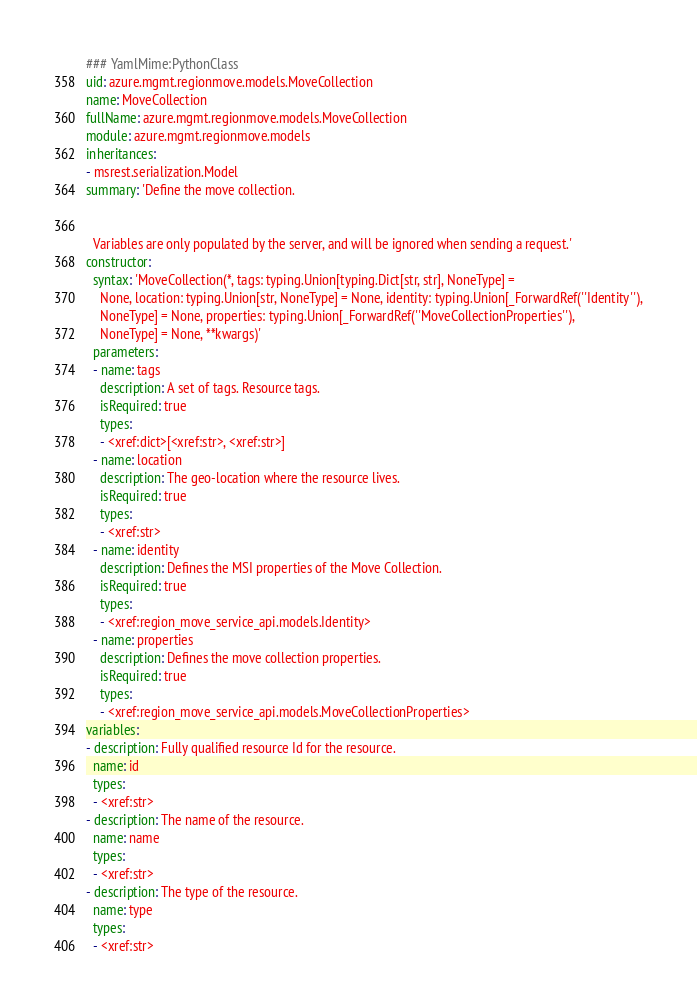Convert code to text. <code><loc_0><loc_0><loc_500><loc_500><_YAML_>### YamlMime:PythonClass
uid: azure.mgmt.regionmove.models.MoveCollection
name: MoveCollection
fullName: azure.mgmt.regionmove.models.MoveCollection
module: azure.mgmt.regionmove.models
inheritances:
- msrest.serialization.Model
summary: 'Define the move collection.


  Variables are only populated by the server, and will be ignored when sending a request.'
constructor:
  syntax: 'MoveCollection(*, tags: typing.Union[typing.Dict[str, str], NoneType] =
    None, location: typing.Union[str, NoneType] = None, identity: typing.Union[_ForwardRef(''Identity''),
    NoneType] = None, properties: typing.Union[_ForwardRef(''MoveCollectionProperties''),
    NoneType] = None, **kwargs)'
  parameters:
  - name: tags
    description: A set of tags. Resource tags.
    isRequired: true
    types:
    - <xref:dict>[<xref:str>, <xref:str>]
  - name: location
    description: The geo-location where the resource lives.
    isRequired: true
    types:
    - <xref:str>
  - name: identity
    description: Defines the MSI properties of the Move Collection.
    isRequired: true
    types:
    - <xref:region_move_service_api.models.Identity>
  - name: properties
    description: Defines the move collection properties.
    isRequired: true
    types:
    - <xref:region_move_service_api.models.MoveCollectionProperties>
variables:
- description: Fully qualified resource Id for the resource.
  name: id
  types:
  - <xref:str>
- description: The name of the resource.
  name: name
  types:
  - <xref:str>
- description: The type of the resource.
  name: type
  types:
  - <xref:str>
</code> 